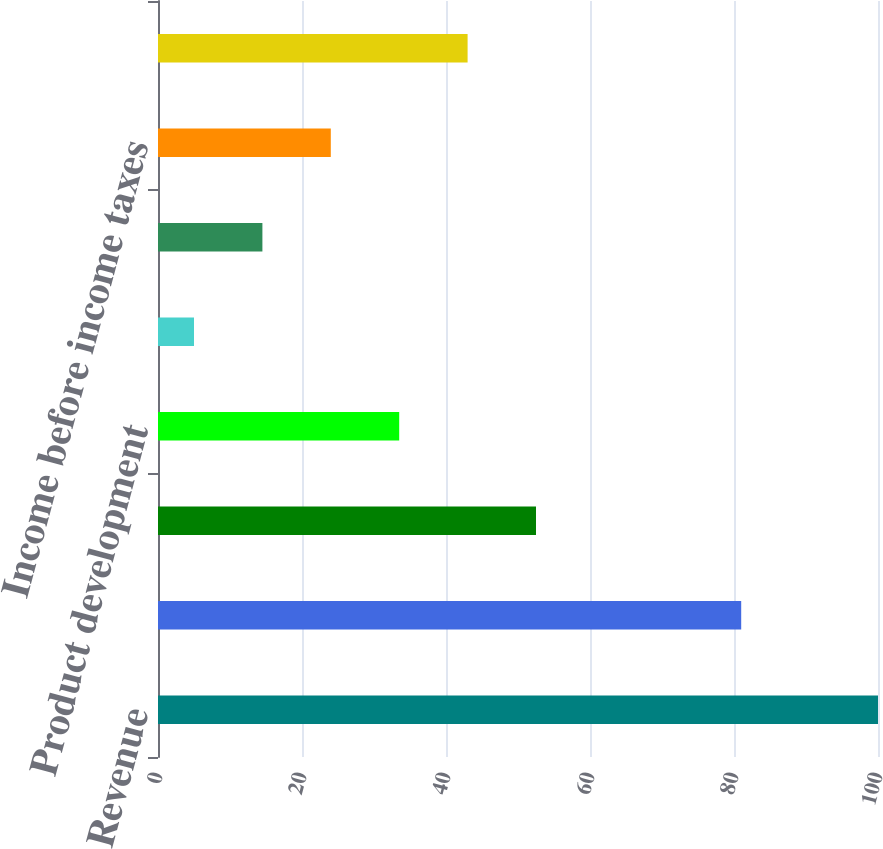Convert chart. <chart><loc_0><loc_0><loc_500><loc_500><bar_chart><fcel>Revenue<fcel>Cost of revenue<fcel>Gross margin<fcel>Product development<fcel>Marketing and administrative<fcel>Income from operations<fcel>Income before income taxes<fcel>Net income<nl><fcel>100<fcel>81<fcel>52.5<fcel>33.5<fcel>5<fcel>14.5<fcel>24<fcel>43<nl></chart> 